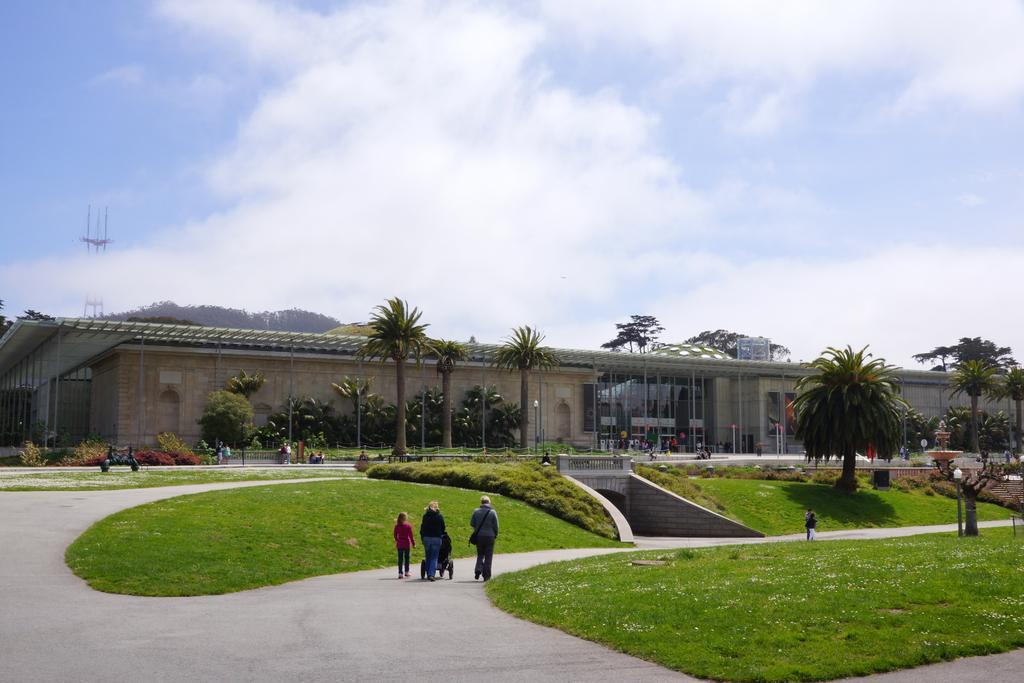Describe this image in one or two sentences. In the picture we can see these people walking on the road, we can see grasslands, trees, building, light poles and the sky with clouds in the background. 